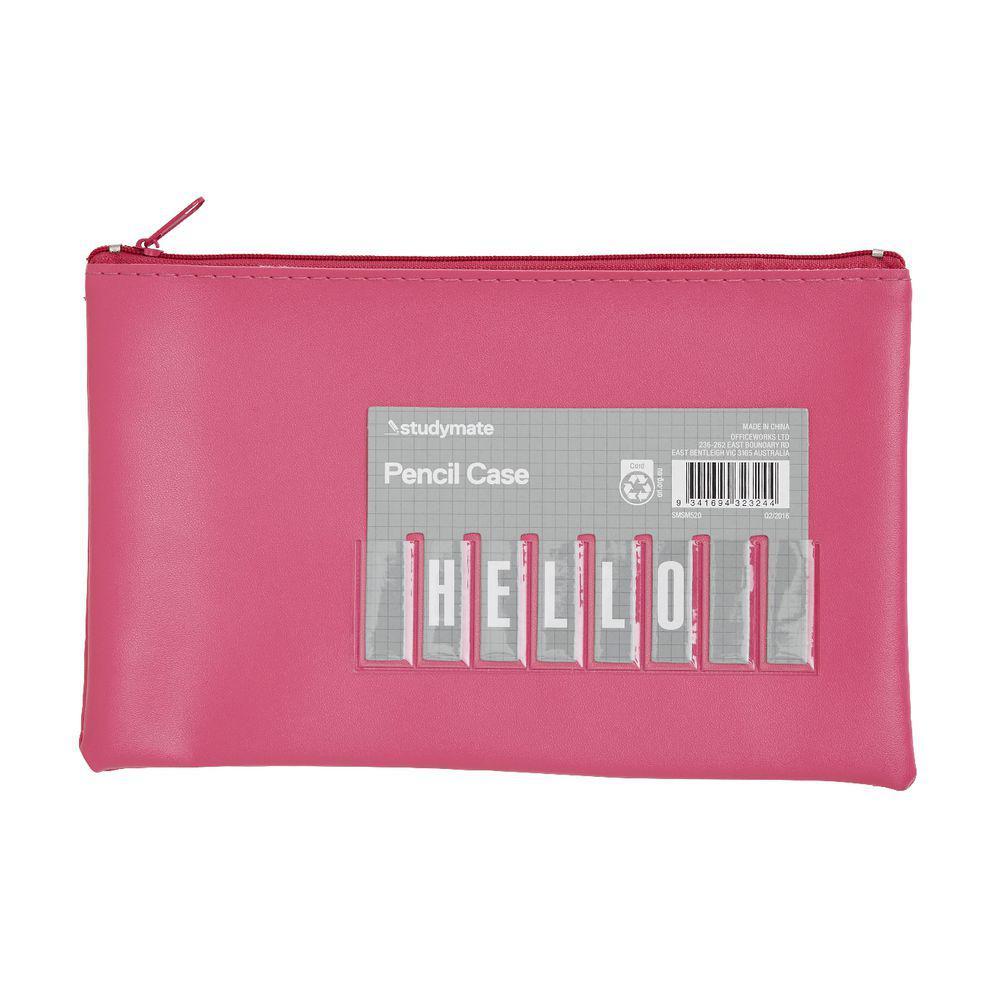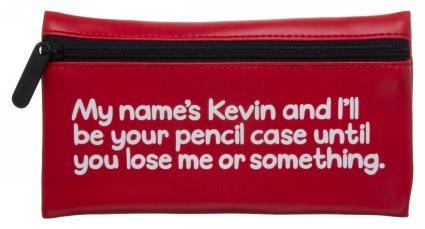The first image is the image on the left, the second image is the image on the right. Evaluate the accuracy of this statement regarding the images: "Each case has a single zipper and a rectangular shape with non-rounded bottom corners, and one case has a gray card on the front.". Is it true? Answer yes or no. Yes. 